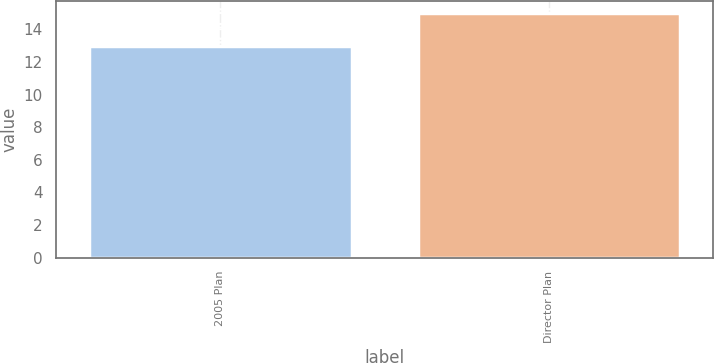Convert chart to OTSL. <chart><loc_0><loc_0><loc_500><loc_500><bar_chart><fcel>2005 Plan<fcel>Director Plan<nl><fcel>13<fcel>15<nl></chart> 